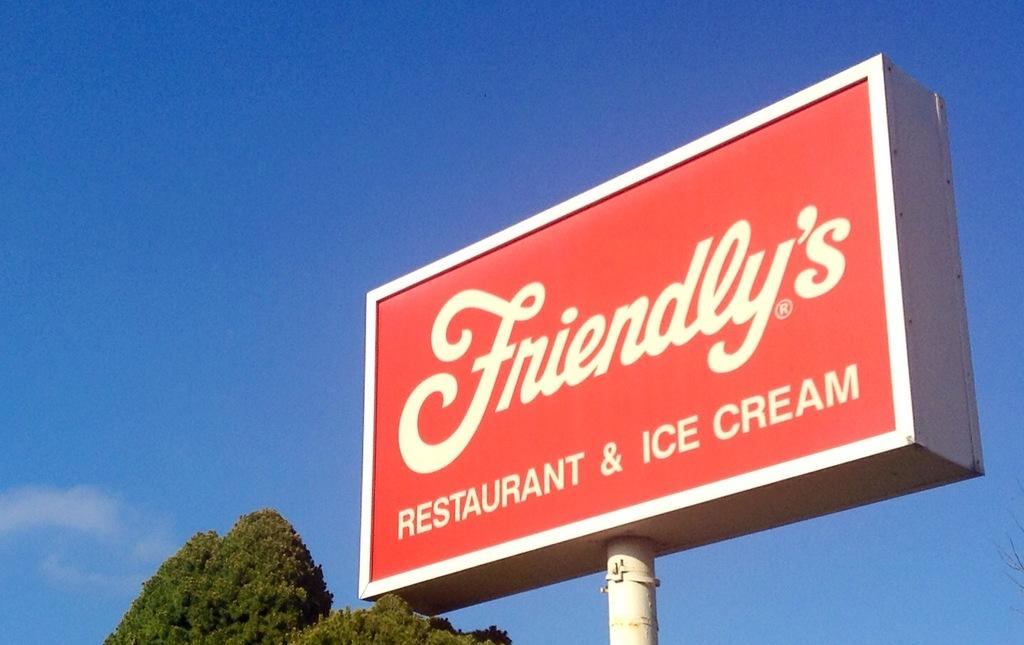<image>
Offer a succinct explanation of the picture presented. A big red business sign with white writing saying "Friendly's Restaurant & Ice Cream." 